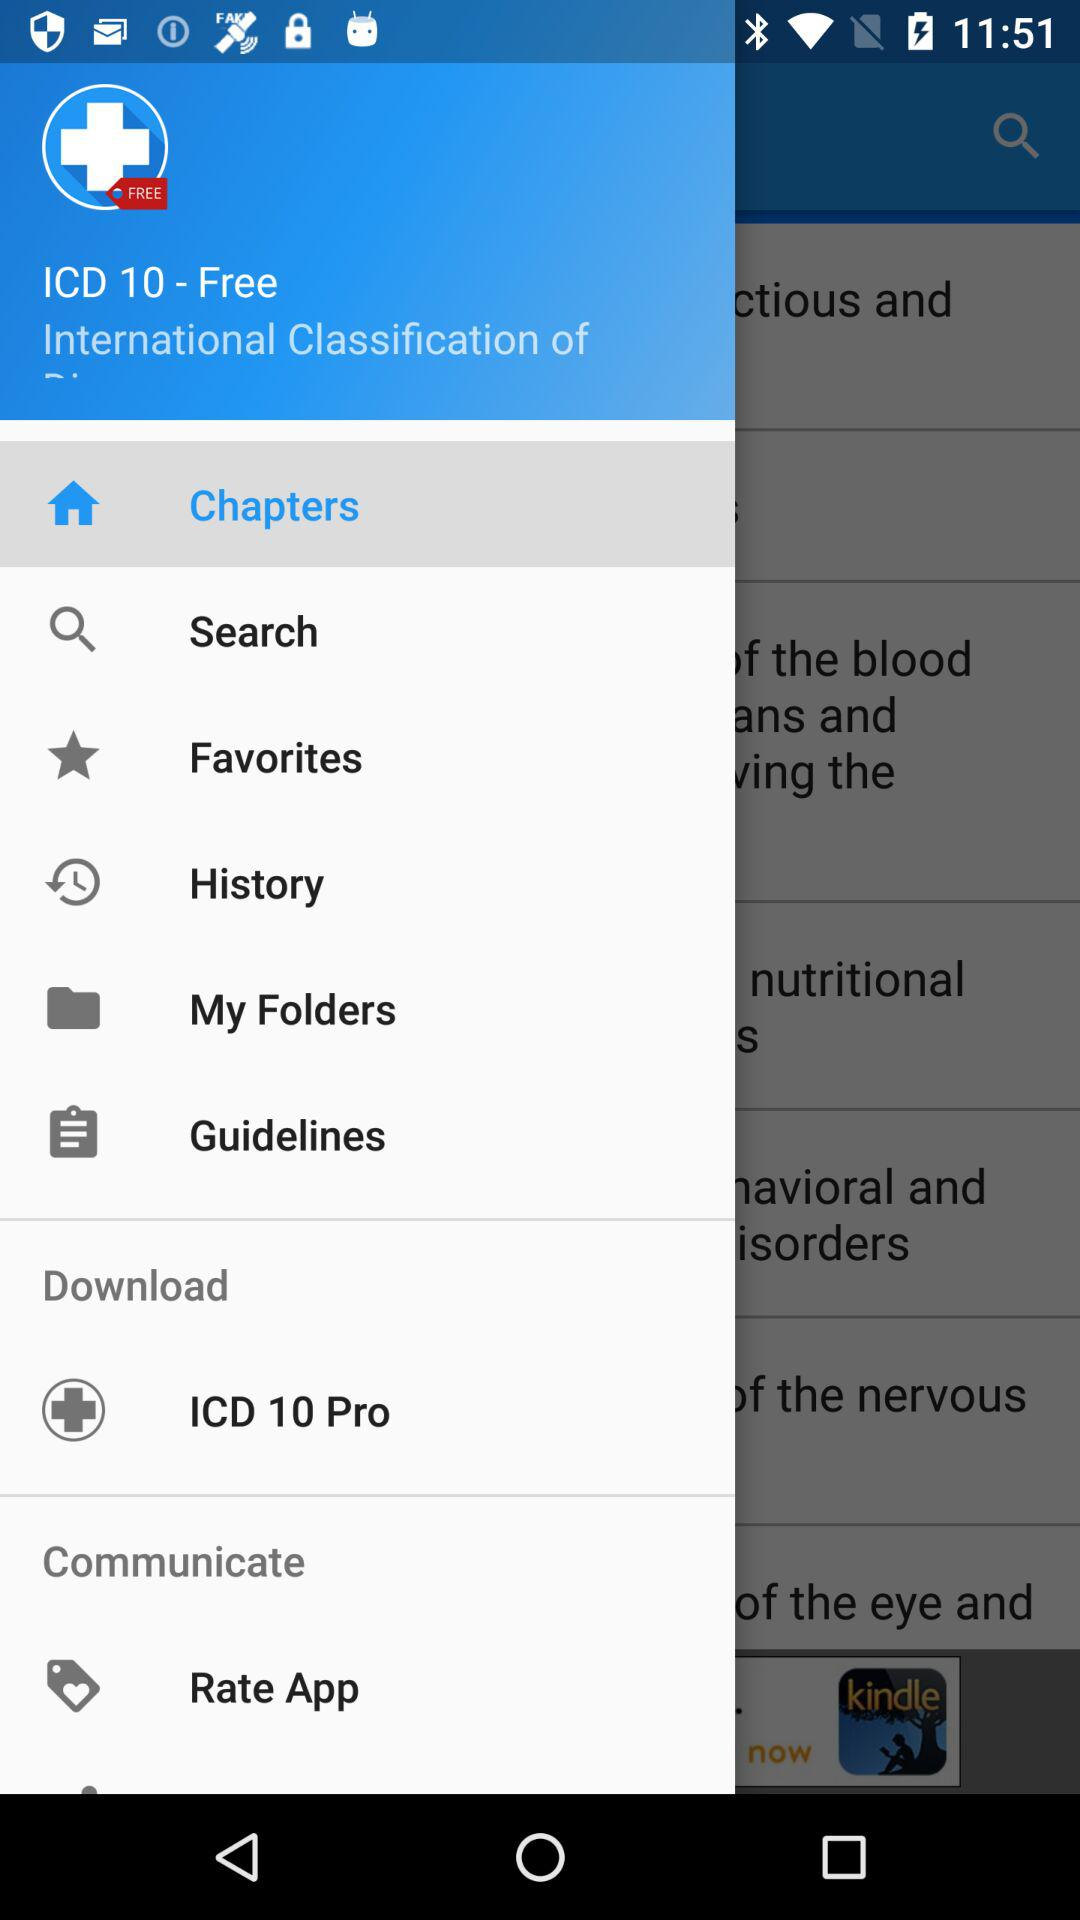What is the application name? The application name is "ICD 10". 